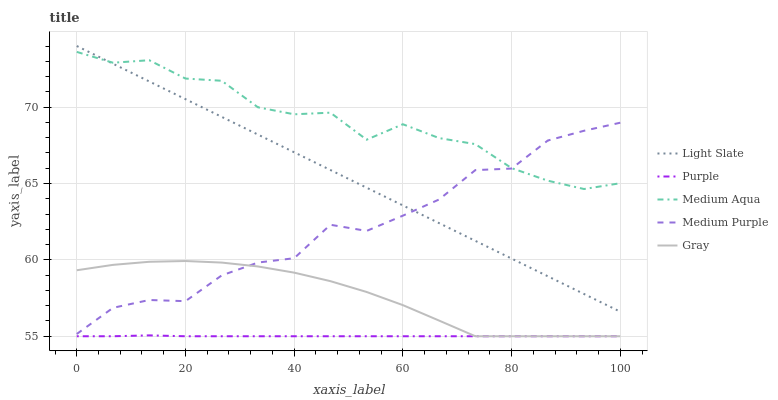Does Purple have the minimum area under the curve?
Answer yes or no. Yes. Does Medium Aqua have the maximum area under the curve?
Answer yes or no. Yes. Does Medium Purple have the minimum area under the curve?
Answer yes or no. No. Does Medium Purple have the maximum area under the curve?
Answer yes or no. No. Is Light Slate the smoothest?
Answer yes or no. Yes. Is Medium Aqua the roughest?
Answer yes or no. Yes. Is Purple the smoothest?
Answer yes or no. No. Is Purple the roughest?
Answer yes or no. No. Does Purple have the lowest value?
Answer yes or no. Yes. Does Medium Purple have the lowest value?
Answer yes or no. No. Does Light Slate have the highest value?
Answer yes or no. Yes. Does Medium Purple have the highest value?
Answer yes or no. No. Is Gray less than Medium Aqua?
Answer yes or no. Yes. Is Medium Aqua greater than Gray?
Answer yes or no. Yes. Does Medium Purple intersect Medium Aqua?
Answer yes or no. Yes. Is Medium Purple less than Medium Aqua?
Answer yes or no. No. Is Medium Purple greater than Medium Aqua?
Answer yes or no. No. Does Gray intersect Medium Aqua?
Answer yes or no. No. 